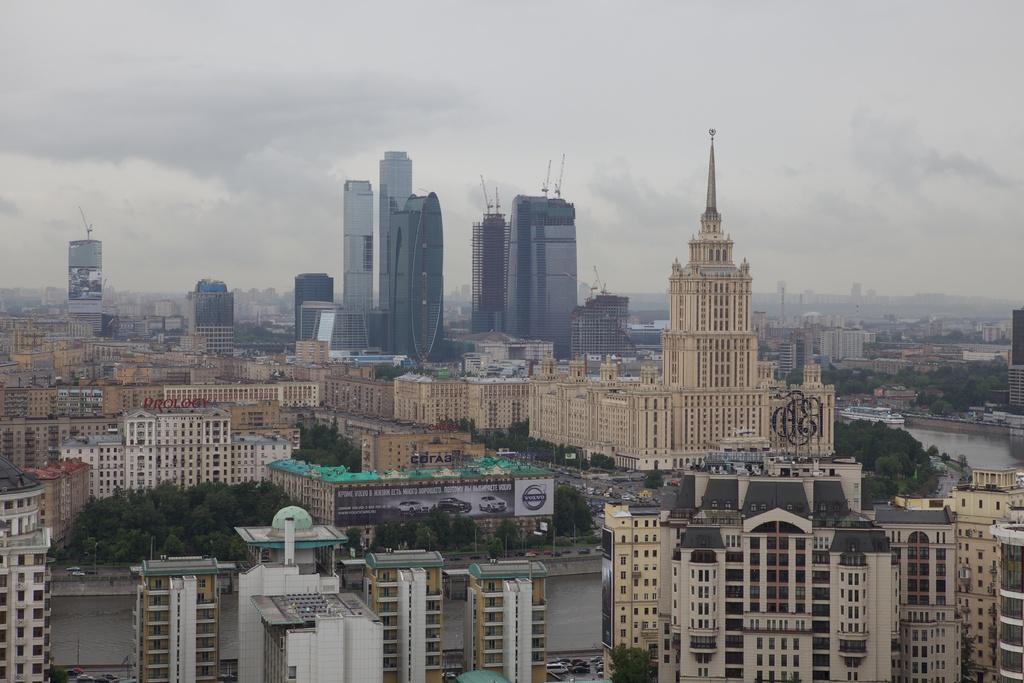What can be seen at the bottom of the image? There are trees, buildings, water, and vehicles at the bottom of the image. What is present on the water in the image? There are ships on the water. What is visible in the sky at the top of the image? There are clouds in the sky at the top of the image. Can you see your dad sparking a quiver in the image? There is no reference to a dad, spark, or quiver in the image. 